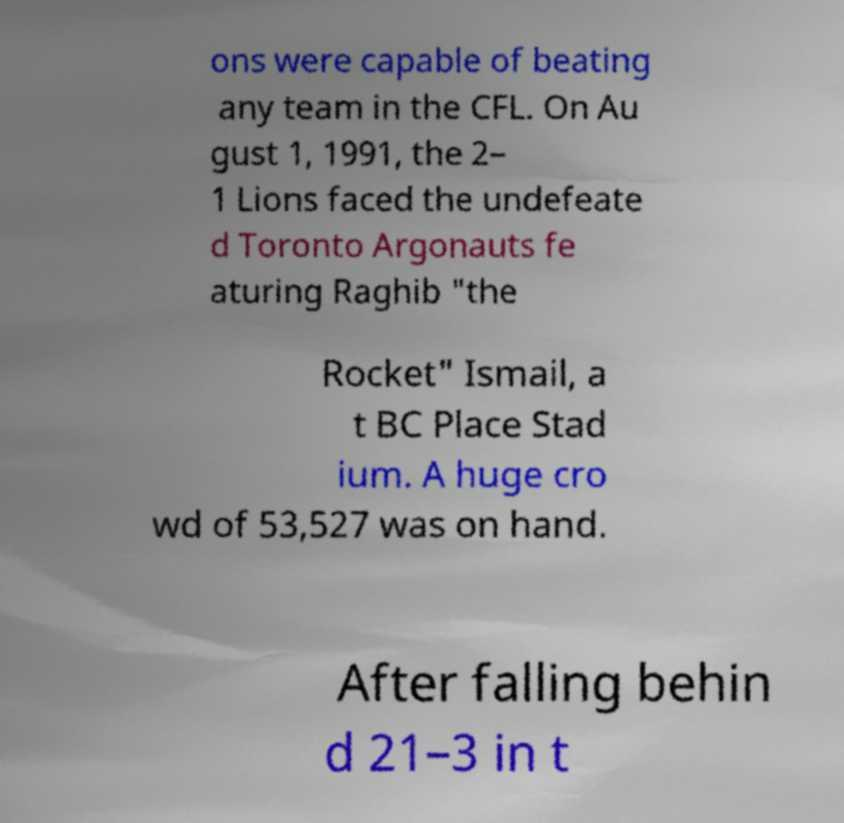Please read and relay the text visible in this image. What does it say? ons were capable of beating any team in the CFL. On Au gust 1, 1991, the 2– 1 Lions faced the undefeate d Toronto Argonauts fe aturing Raghib "the Rocket" Ismail, a t BC Place Stad ium. A huge cro wd of 53,527 was on hand. After falling behin d 21–3 in t 